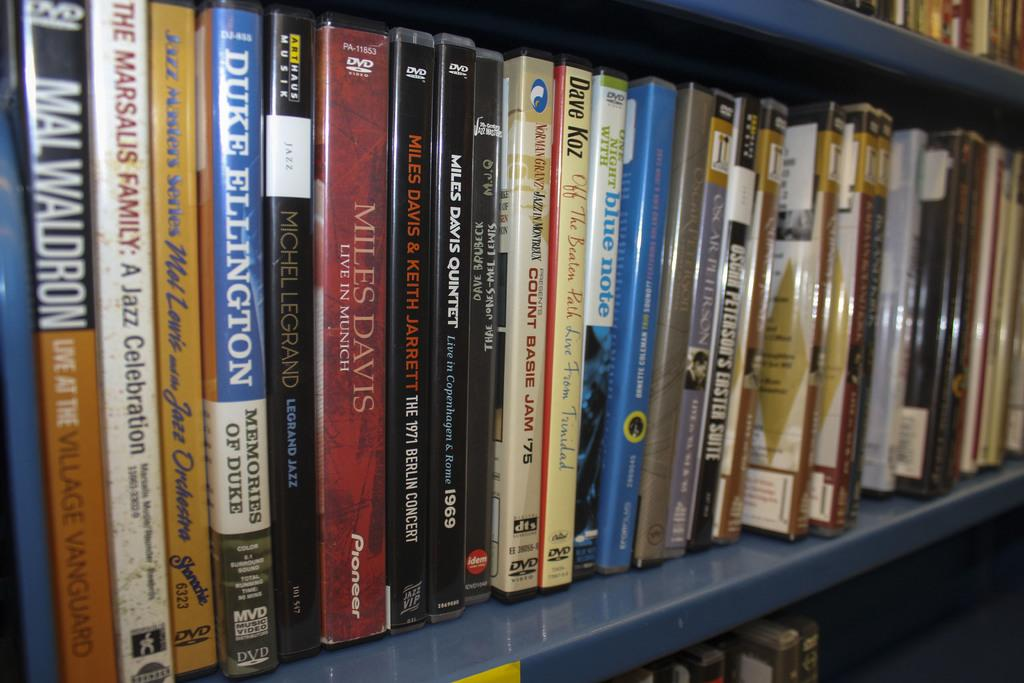Provide a one-sentence caption for the provided image. A large amount of books on shelves and one of them is about Duke Ellington. 